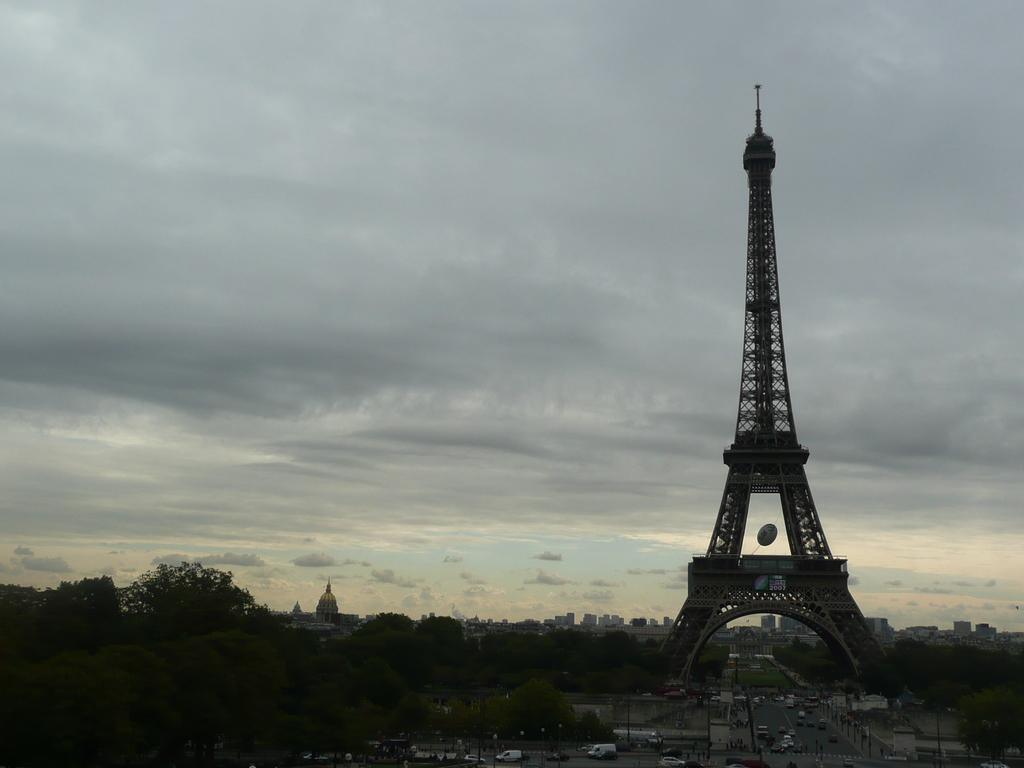What famous landmark can be seen on the right side of the image? There is an Eiffel Tower on the right side of the image. What is happening at the bottom of the image? Vehicles are visible on the road at the bottom of the image. What type of natural elements can be seen in the background of the image? There are trees in the background of the image. What type of man-made structures can be seen in the background of the image? There are buildings in the background of the image. What is visible in the sky in the background of the image? The sky is visible in the background of the image. What type of leather is used to make the furniture in the image? There is no furniture present in the image, so it is not possible to determine the type of leather used. 